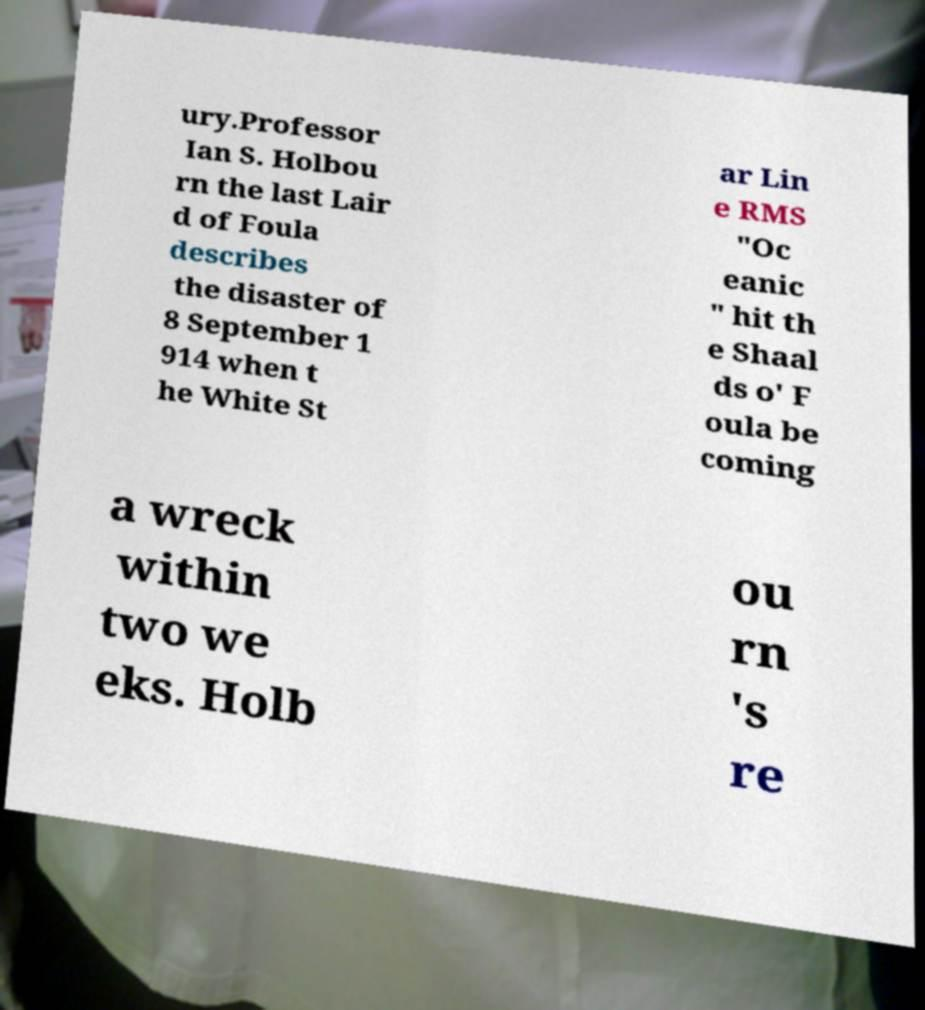Please identify and transcribe the text found in this image. ury.Professor Ian S. Holbou rn the last Lair d of Foula describes the disaster of 8 September 1 914 when t he White St ar Lin e RMS "Oc eanic " hit th e Shaal ds o' F oula be coming a wreck within two we eks. Holb ou rn 's re 